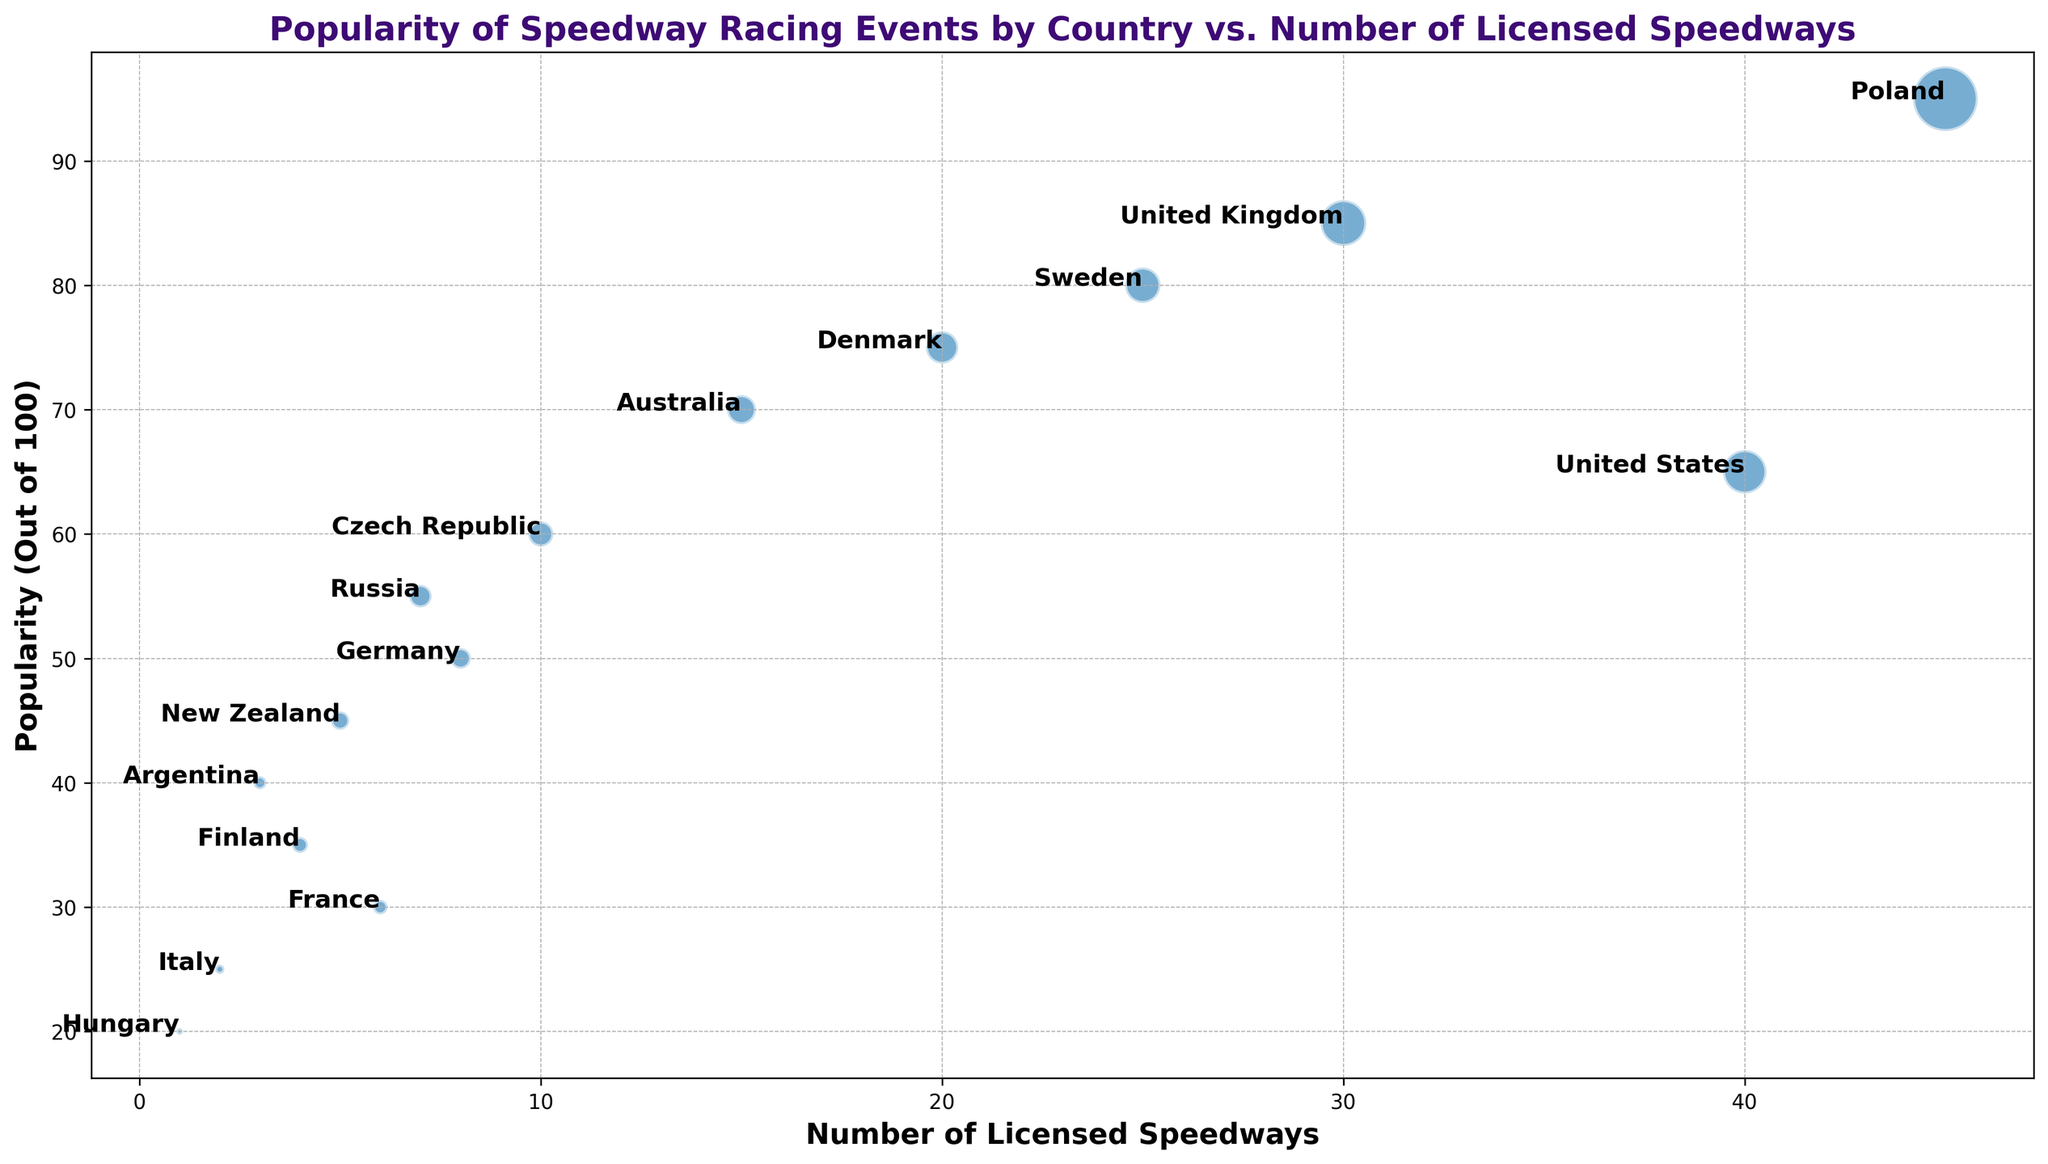Which country has the highest popularity in speedway racing? Poland has the highest popularity, clearly shown by its position at the top of the y-axis.
Answer: Poland What is the total number of licensed speedways in the countries with popularity above 70? The countries with popularity above 70 are Poland (45), United Kingdom (30), Sweden (25), and Denmark (20). Sum = 45 + 30 + 25 + 20 = 120
Answer: 120 Which two countries have the closest number of licensed speedways, and what are their popularity levels? France (6) and Russia (7) have the closest number of licensed speedways. Their popularity levels are 30 and 55, respectively.
Answer: France: 30, Russia: 55 What can you say about the attendance size of speedway events with respect to popularity? The bubble sizes indicate attendance. Larger bubbles are generally associated with higher popularity; for example, Poland has a large bubble and high popularity, while smaller bubbles like those of Hungary and Italy correspond to lower popularity.
Answer: Higher popularity often correlates with larger attendance Which country has the lowest number of licensed speedways, and how popular is speedway racing there? Hungary has the lowest number of licensed speedways (1), and its popularity is 20.
Answer: Hungary: 20 Identify the country with the largest bubble and provide its popularity and number of licensed speedways. Poland has the largest bubble, indicating the largest attendance. Its popularity is 95, and it has 45 licensed speedways.
Answer: Poland: 95, 45 How does the number of licensed speedways in the United States compare to that in Poland? The United States has 40 licensed speedways, whereas Poland has 45. Therefore, Poland has 5 more licensed speedways than the United States.
Answer: Poland has 5 more Which countries have a higher popularity than the number of licensed speedways, and by how much for each? Poland: 50 more (95 - 45), United Kingdom: 55 more (85 - 30), Sweden: 55 more (80 - 25), Denmark: 55 more (75 - 20), Australia: 55 more (70 - 15), Czech Republic: 50 more (60 - 10), Russia: 48 more (55 - 7), Germany: 42 more (50 - 8), New Zealand: 40 more (45 - 5), Argentina: 37 more (40 - 3), Finland: 31 more (35 - 4), France: 24 more (30 - 6), Italy: 23 more (25 - 2), Hungary: 19 more (20 - 1)
Answer: Various: Poland 50, UK 55, Sweden 55, Denmark 55, Australia 55, Czech Rep 50, Russia 48, Germany 42, New Zealand 40, Argentina 37, Finland 31, France 24, Italy 23, Hungary 19 Which countries have fewer than 10 licensed speedways, and what's their combined popularity? Czech Republic (10), Russia (7), Germany (8), New Zealand (5), Argentina (3), Finland (4), France (6), Italy (2), and Hungary (1) have fewer than 10 licensed speedways. Their combined popularity is 60 + 55 + 50 + 45 + 40 + 35 + 30 + 25 + 20 = 360.
Answer: 360 